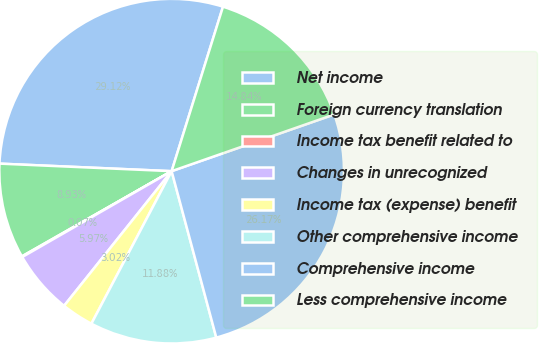Convert chart. <chart><loc_0><loc_0><loc_500><loc_500><pie_chart><fcel>Net income<fcel>Foreign currency translation<fcel>Income tax benefit related to<fcel>Changes in unrecognized<fcel>Income tax (expense) benefit<fcel>Other comprehensive income<fcel>Comprehensive income<fcel>Less comprehensive income<nl><fcel>29.12%<fcel>8.93%<fcel>0.07%<fcel>5.97%<fcel>3.02%<fcel>11.88%<fcel>26.17%<fcel>14.84%<nl></chart> 